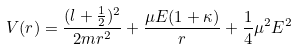<formula> <loc_0><loc_0><loc_500><loc_500>V ( r ) = \frac { ( l + \frac { 1 } { 2 } ) ^ { 2 } } { 2 m r ^ { 2 } } + \frac { \mu E ( 1 + \kappa ) } { r } + \frac { 1 } { 4 } \mu ^ { 2 } E ^ { 2 }</formula> 